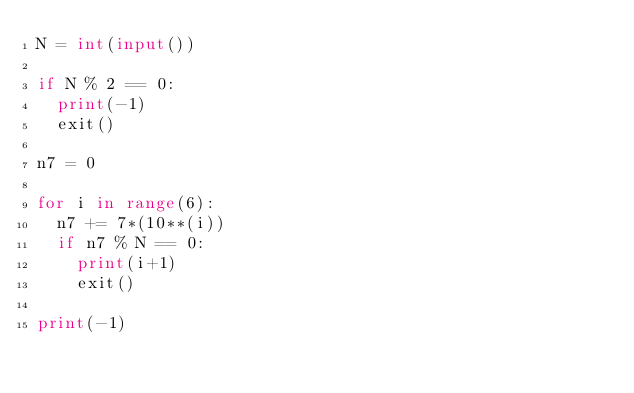Convert code to text. <code><loc_0><loc_0><loc_500><loc_500><_Python_>N = int(input())

if N % 2 == 0:
  print(-1)
  exit()

n7 = 0
 
for i in range(6):
  n7 += 7*(10**(i))
  if n7 % N == 0:
    print(i+1)
    exit()

print(-1)</code> 